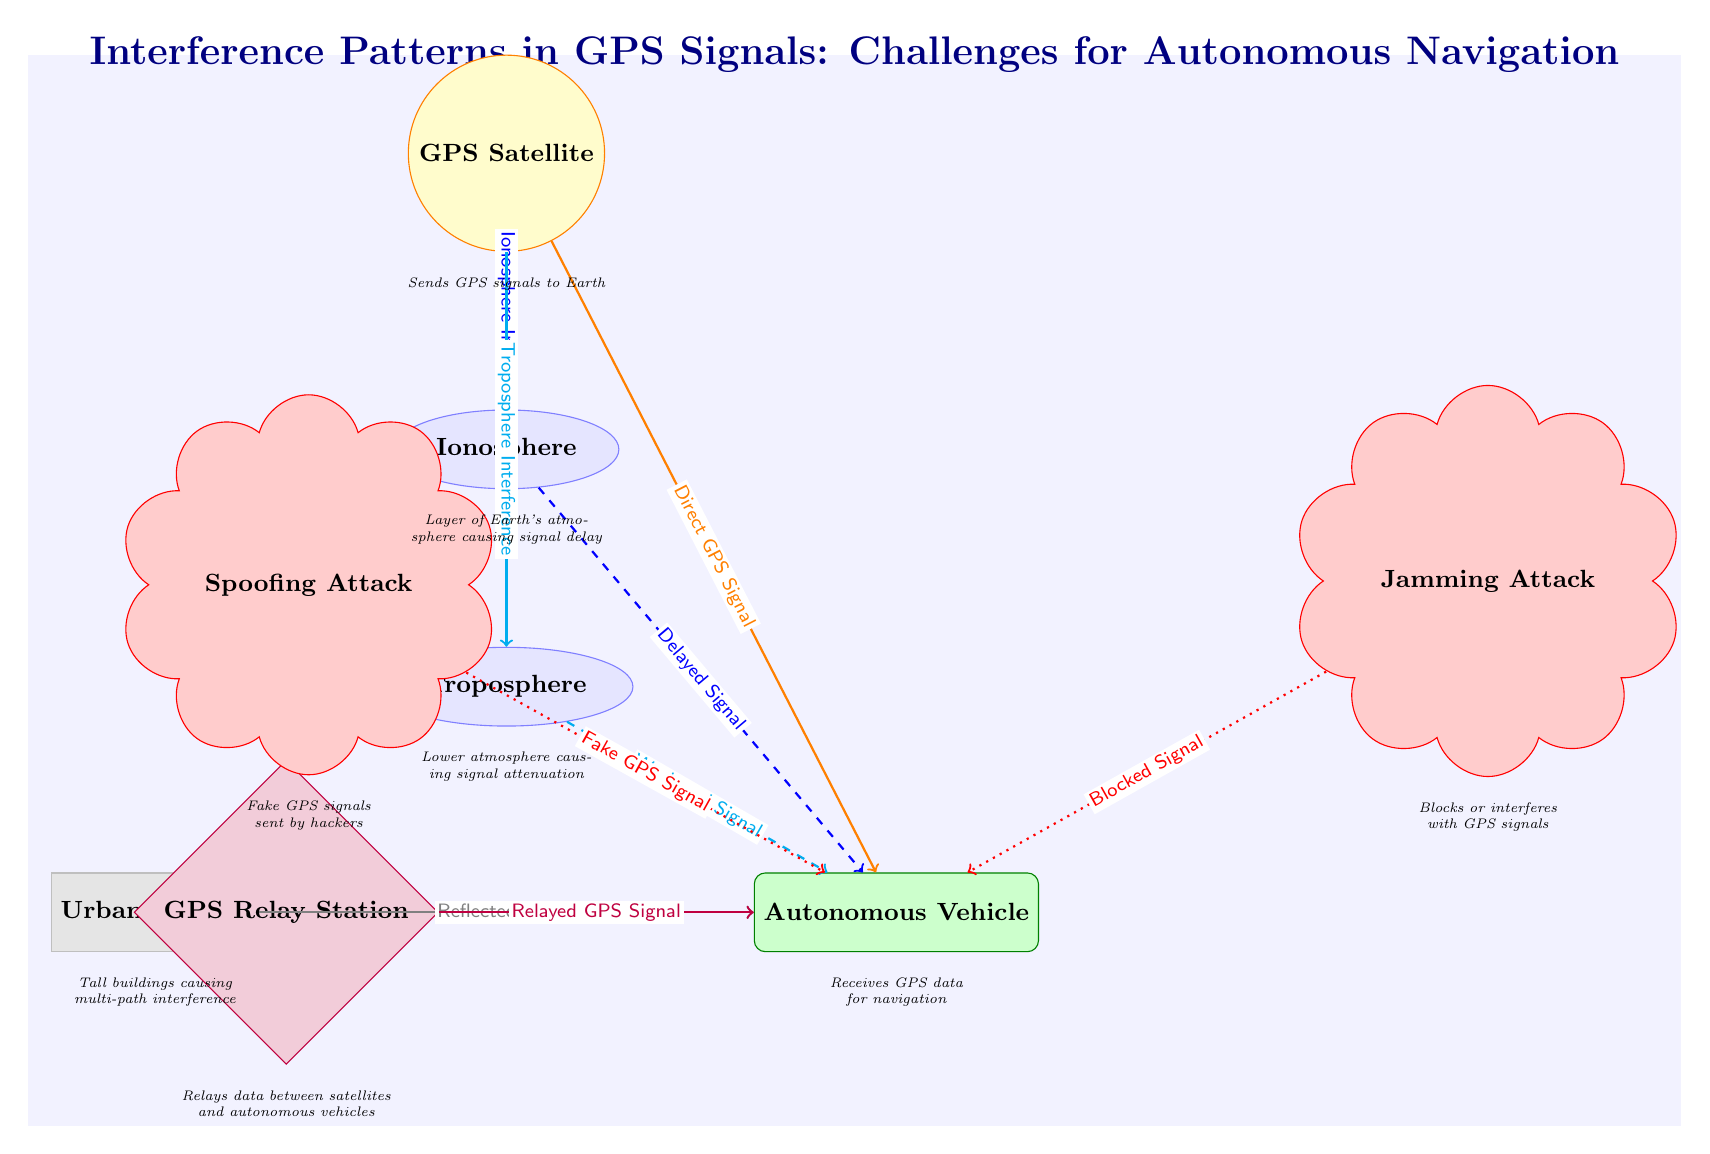What type of node is the "GPS Satellite"? The diagram labels the "GPS Satellite" as a circular node, which is categorized under the style defined for satellites. Each node's representation in the diagram is based on the defined styles in the code, and since "GPS Satellite" is styled as a circle, it is identified as a satellite node.
Answer: Satellite How many layers of atmosphere are represented in the diagram? In the diagram, two atmospheric layers are explicitly mentioned: the Ionosphere and the Troposphere. They are visually distinguished by their respective shapes (ellipses) and labeled accordingly. Counting these items gives a total of two layers of atmosphere.
Answer: 2 What type of attack is indicated to send a fake GPS signal? The node labeled "Spoofing Attack" specifies that it sends a fake GPS signal to the autonomous vehicle. The descriptive nature of the label provides this specific information about the type of attack conducted by hackers.
Answer: Spoofing Attack What is the relationship between the GPS Relay Station and the Autonomous Vehicle? The relationship is indicated by a directed edge that is labeled as "Relayed GPS Signal". This edge indicates that the GPS relay station sends necessary GPS data that assists the autonomous vehicle in navigation, establishing a clear connection between the two nodes.
Answer: Relayed GPS Signal Which node causes multi-path interference? The "Urban Canyon" node is explicitly stated to cause multi-path interference, as described by the information box that mentions "Tall buildings causing multi-path interference". Thus, it is the source of this specific type of signal issue for the autonomous vehicle.
Answer: Urban Canyon What kind of signal is affected by Jamming Attack? The "Blocked Signal" is the type of signal affected by the Jamming Attack, as labeled in the diagram. This relationship illustrates that such attacks interfere with the signal necessary for the autonomous vehicle's navigation.
Answer: Blocked Signal What effect does the Ionosphere have on GPS signals? The diagram shows an arrow from the satellite to the Ionosphere with a label saying "Ionosphere Interference". Additionally, there is a dashed arrow connecting the Ionosphere to the Autonomous Vehicle labeled "Delayed Signal". This indicates the Ionosphere introduces interference that results in delays of the GPS signals reaching the vehicle.
Answer: Delayed Signal What is indicated by the arrow labeled "Reflected Signal"? This arrow leading from the "Urban Canyon" node to the "Autonomous Vehicle" signifies the existence of reflections caused by tall buildings that affect the GPS signals received by the vehicle. This reflects the real-world scenario where buildings can adversely impact navigation.
Answer: Reflected Signal 